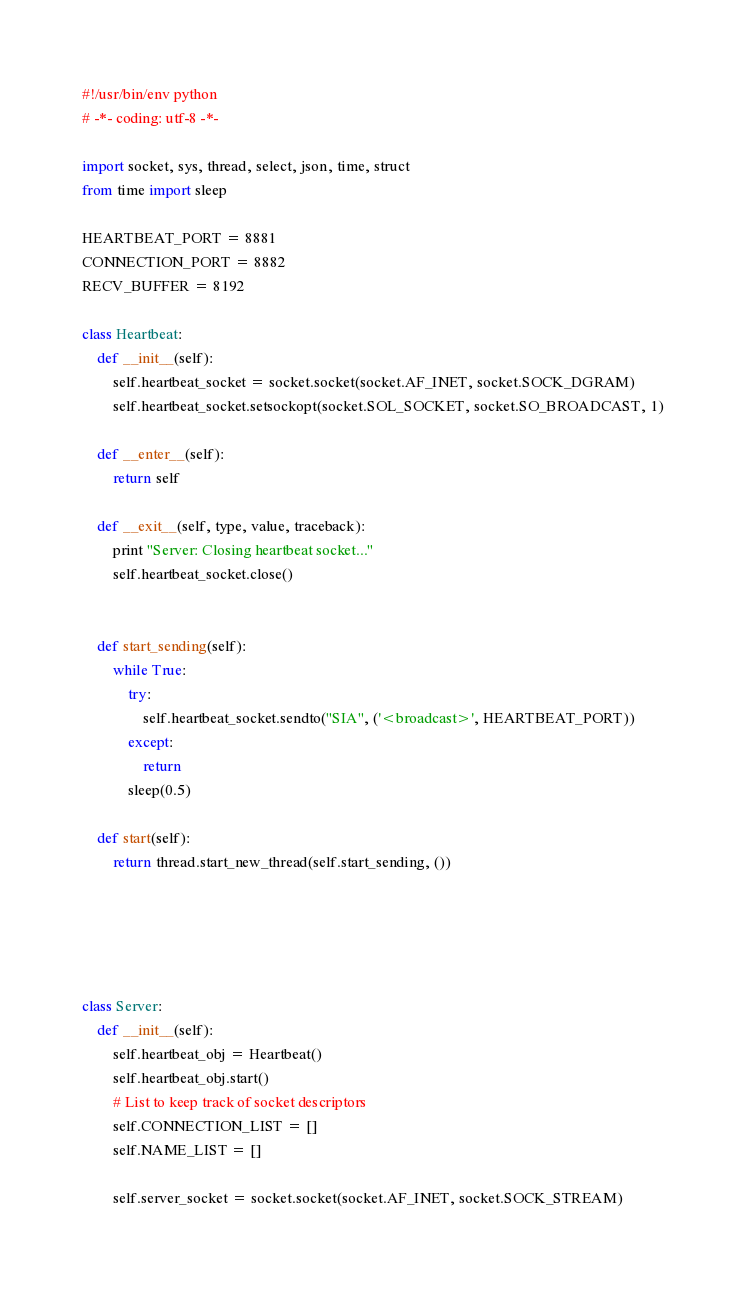Convert code to text. <code><loc_0><loc_0><loc_500><loc_500><_Python_>#!/usr/bin/env python
# -*- coding: utf-8 -*-

import socket, sys, thread, select, json, time, struct
from time import sleep

HEARTBEAT_PORT = 8881
CONNECTION_PORT = 8882
RECV_BUFFER = 8192

class Heartbeat:
    def __init__(self):
        self.heartbeat_socket = socket.socket(socket.AF_INET, socket.SOCK_DGRAM)
        self.heartbeat_socket.setsockopt(socket.SOL_SOCKET, socket.SO_BROADCAST, 1)

    def __enter__(self):
        return self
    
    def __exit__(self, type, value, traceback):
        print "Server: Closing heartbeat socket..."
        self.heartbeat_socket.close()
        
        
    def start_sending(self):
        while True:
            try:
                self.heartbeat_socket.sendto("SIA", ('<broadcast>', HEARTBEAT_PORT))
            except:
                return
            sleep(0.5)

    def start(self):
        return thread.start_new_thread(self.start_sending, ())
    

 


class Server:
    def __init__(self):
        self.heartbeat_obj = Heartbeat()
        self.heartbeat_obj.start()
        # List to keep track of socket descriptors
        self.CONNECTION_LIST = []
        self.NAME_LIST = []
         
        self.server_socket = socket.socket(socket.AF_INET, socket.SOCK_STREAM)</code> 